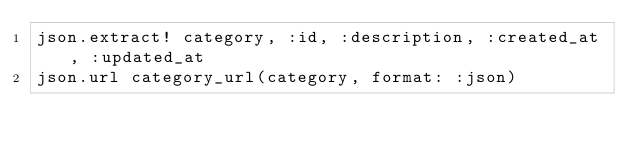Convert code to text. <code><loc_0><loc_0><loc_500><loc_500><_Ruby_>json.extract! category, :id, :description, :created_at, :updated_at
json.url category_url(category, format: :json)
</code> 